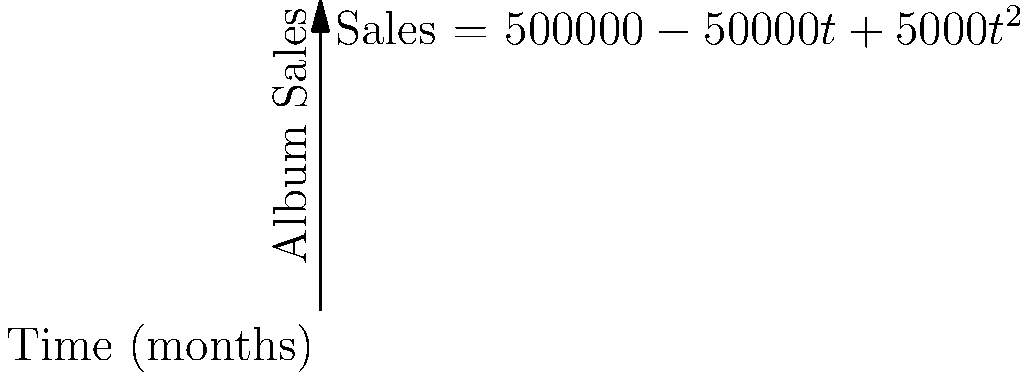Lady Gaga's latest album sales follow the function $S(t) = 500000 - 50000t + 5000t^2$, where $S$ is the number of albums sold and $t$ is the time in months since release. At what point in time is the rate of change in album sales equal to zero? To find when the rate of change in album sales is zero, we need to follow these steps:

1) The rate of change is given by the derivative of the sales function. Let's call this $S'(t)$.

2) Calculate the derivative:
   $S'(t) = -50000 + 10000t$

3) Set the derivative equal to zero and solve for $t$:
   $S'(t) = 0$
   $-50000 + 10000t = 0$
   $10000t = 50000$
   $t = 5$

4) Check the second derivative to confirm this is a minimum:
   $S''(t) = 10000 > 0$, so this is indeed a minimum.

5) Interpret the result: The rate of change in album sales is zero at 5 months after release. This is when sales reach their lowest point before starting to increase again.

This analysis shows how Lady Gaga's album sales initially decrease but then start to pick up again, possibly due to increased promotion or word-of-mouth recommendations.
Answer: 5 months 